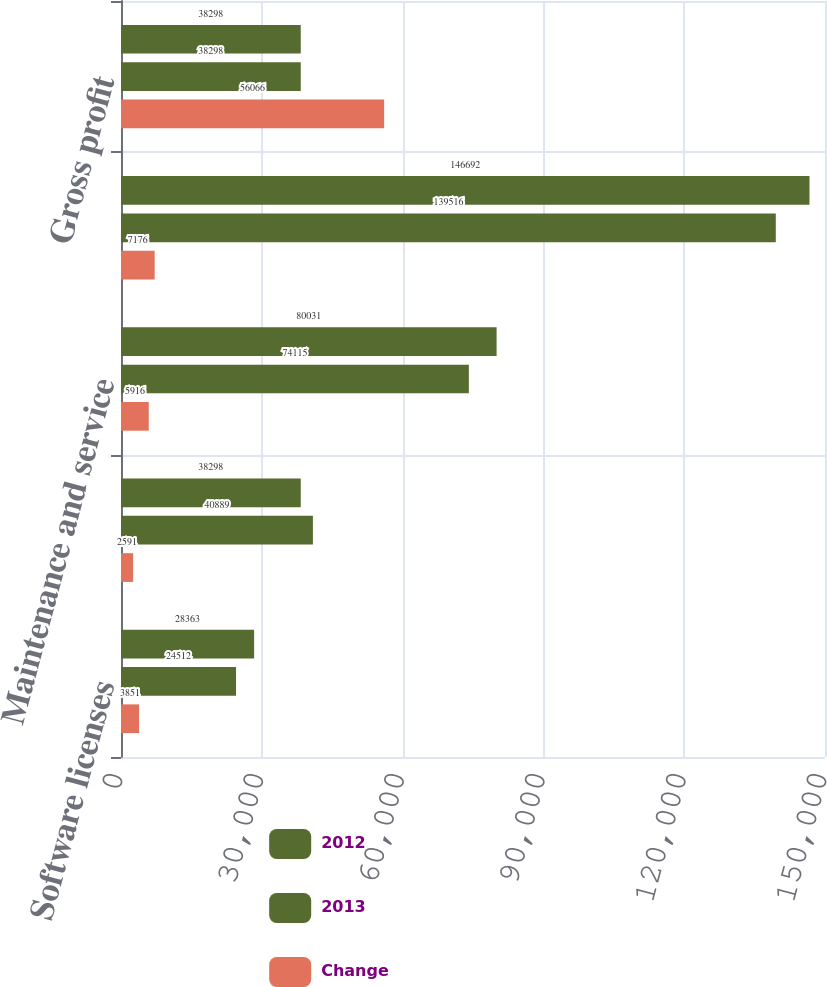Convert chart to OTSL. <chart><loc_0><loc_0><loc_500><loc_500><stacked_bar_chart><ecel><fcel>Software licenses<fcel>Amortization<fcel>Maintenance and service<fcel>Total cost of sales<fcel>Gross profit<nl><fcel>2012<fcel>28363<fcel>38298<fcel>80031<fcel>146692<fcel>38298<nl><fcel>2013<fcel>24512<fcel>40889<fcel>74115<fcel>139516<fcel>38298<nl><fcel>Change<fcel>3851<fcel>2591<fcel>5916<fcel>7176<fcel>56066<nl></chart> 